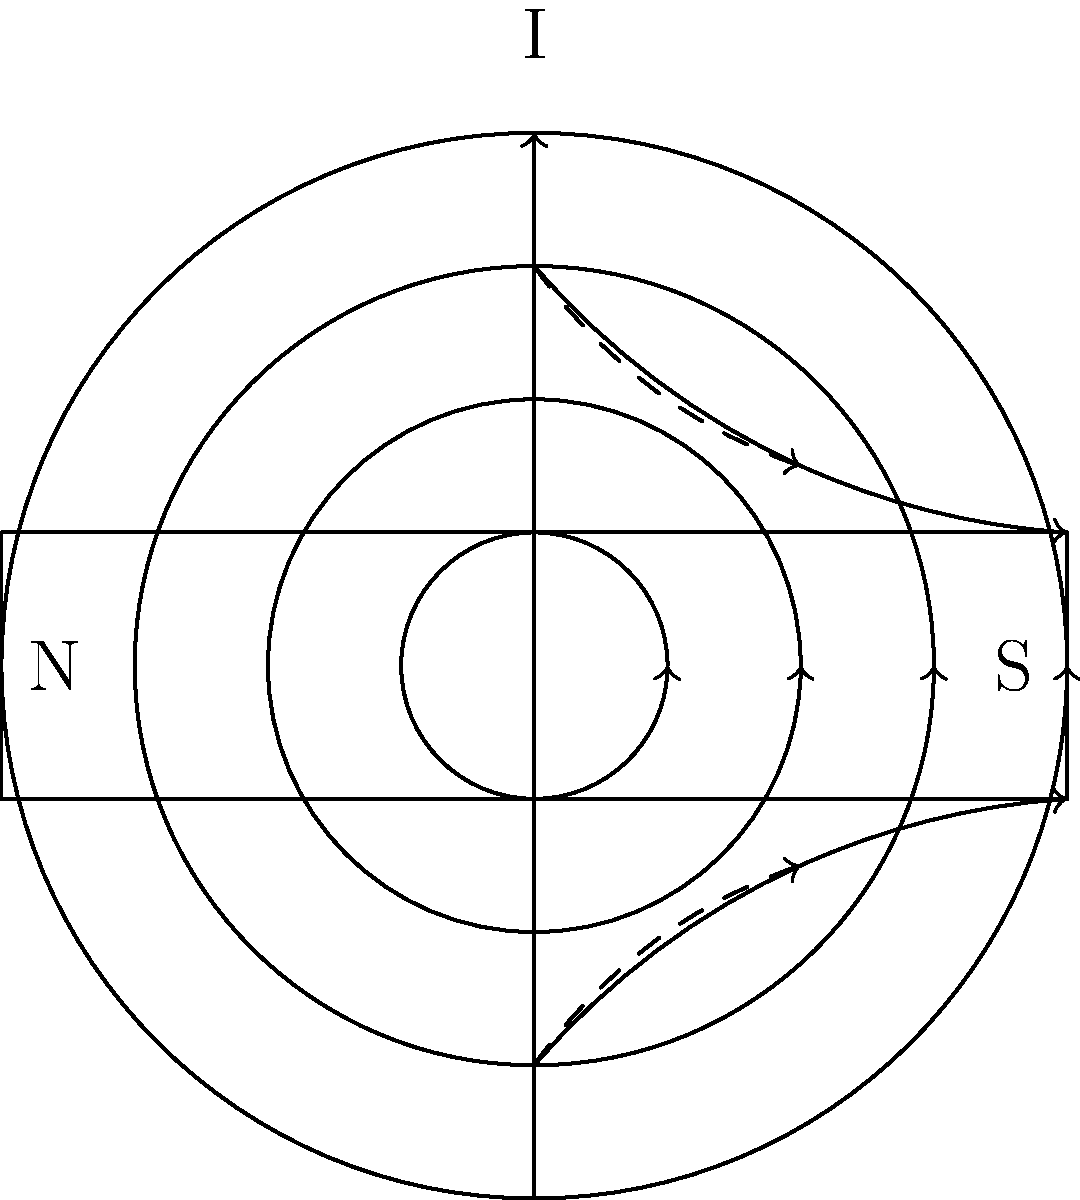In the diagram above, a current-carrying wire is placed near a permanent magnet. The current in the wire flows upward, and the magnetic field lines of both the wire and the magnet are shown. Based on this configuration, what will be the direction of the resultant magnetic force acting on the wire? To determine the direction of the resultant magnetic force on the wire, we need to analyze the interaction between the magnetic fields of the wire and the permanent magnet. Let's follow these steps:

1. Magnetic field of the wire:
   - The magnetic field lines around the wire form concentric circles in the counterclockwise direction (using the right-hand rule for a current flowing upward).

2. Magnetic field of the permanent magnet:
   - The magnetic field lines go from the North pole to the South pole of the magnet.

3. Superposition of magnetic fields:
   - On the left side of the wire (facing the magnet), the magnetic field lines of the wire and the magnet are in the same direction (both pointing upward).
   - On the right side of the wire, the magnetic field lines are in opposite directions.

4. Resultant field strength:
   - The magnetic field is stronger on the left side of the wire due to the superposition of fields in the same direction.
   - The magnetic field is weaker on the right side of the wire due to the partial cancellation of fields.

5. Force on the wire:
   - According to Ampère's force law, a current-carrying wire in a magnetic field experiences a force perpendicular to both the current and the magnetic field.
   - The force is directed from the stronger field region to the weaker field region.

6. Direction of the force:
   - Since the stronger field is on the left side of the wire, the force will be directed towards the right (away from the magnet).

Therefore, the resultant magnetic force acting on the wire will be directed to the right, away from the permanent magnet.
Answer: To the right (away from the magnet) 